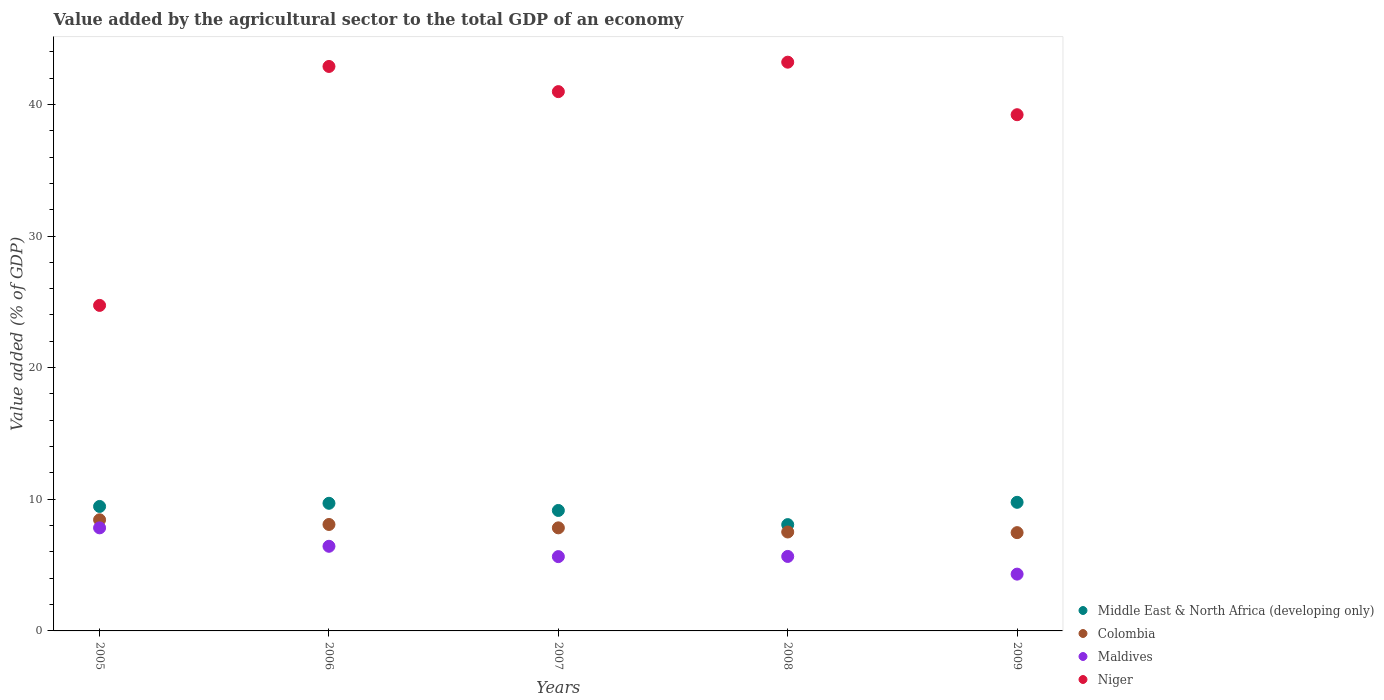How many different coloured dotlines are there?
Ensure brevity in your answer.  4. Is the number of dotlines equal to the number of legend labels?
Provide a succinct answer. Yes. What is the value added by the agricultural sector to the total GDP in Niger in 2008?
Give a very brief answer. 43.21. Across all years, what is the maximum value added by the agricultural sector to the total GDP in Colombia?
Your answer should be very brief. 8.44. Across all years, what is the minimum value added by the agricultural sector to the total GDP in Colombia?
Your answer should be very brief. 7.47. In which year was the value added by the agricultural sector to the total GDP in Middle East & North Africa (developing only) maximum?
Give a very brief answer. 2009. In which year was the value added by the agricultural sector to the total GDP in Middle East & North Africa (developing only) minimum?
Ensure brevity in your answer.  2008. What is the total value added by the agricultural sector to the total GDP in Middle East & North Africa (developing only) in the graph?
Offer a very short reply. 46.15. What is the difference between the value added by the agricultural sector to the total GDP in Middle East & North Africa (developing only) in 2006 and that in 2009?
Offer a terse response. -0.07. What is the difference between the value added by the agricultural sector to the total GDP in Middle East & North Africa (developing only) in 2008 and the value added by the agricultural sector to the total GDP in Colombia in 2009?
Keep it short and to the point. 0.61. What is the average value added by the agricultural sector to the total GDP in Colombia per year?
Your response must be concise. 7.87. In the year 2008, what is the difference between the value added by the agricultural sector to the total GDP in Maldives and value added by the agricultural sector to the total GDP in Middle East & North Africa (developing only)?
Provide a succinct answer. -2.42. What is the ratio of the value added by the agricultural sector to the total GDP in Maldives in 2006 to that in 2009?
Your answer should be very brief. 1.49. What is the difference between the highest and the second highest value added by the agricultural sector to the total GDP in Niger?
Provide a short and direct response. 0.32. What is the difference between the highest and the lowest value added by the agricultural sector to the total GDP in Middle East & North Africa (developing only)?
Give a very brief answer. 1.69. In how many years, is the value added by the agricultural sector to the total GDP in Middle East & North Africa (developing only) greater than the average value added by the agricultural sector to the total GDP in Middle East & North Africa (developing only) taken over all years?
Provide a succinct answer. 3. Is the sum of the value added by the agricultural sector to the total GDP in Niger in 2005 and 2008 greater than the maximum value added by the agricultural sector to the total GDP in Colombia across all years?
Offer a very short reply. Yes. Is it the case that in every year, the sum of the value added by the agricultural sector to the total GDP in Colombia and value added by the agricultural sector to the total GDP in Niger  is greater than the value added by the agricultural sector to the total GDP in Maldives?
Offer a very short reply. Yes. Does the value added by the agricultural sector to the total GDP in Maldives monotonically increase over the years?
Make the answer very short. No. Is the value added by the agricultural sector to the total GDP in Middle East & North Africa (developing only) strictly less than the value added by the agricultural sector to the total GDP in Colombia over the years?
Your response must be concise. No. How many dotlines are there?
Your answer should be compact. 4. Does the graph contain any zero values?
Keep it short and to the point. No. Does the graph contain grids?
Provide a short and direct response. No. Where does the legend appear in the graph?
Your answer should be compact. Bottom right. How many legend labels are there?
Keep it short and to the point. 4. What is the title of the graph?
Offer a terse response. Value added by the agricultural sector to the total GDP of an economy. Does "Brunei Darussalam" appear as one of the legend labels in the graph?
Ensure brevity in your answer.  No. What is the label or title of the Y-axis?
Ensure brevity in your answer.  Value added (% of GDP). What is the Value added (% of GDP) of Middle East & North Africa (developing only) in 2005?
Give a very brief answer. 9.46. What is the Value added (% of GDP) of Colombia in 2005?
Offer a very short reply. 8.44. What is the Value added (% of GDP) in Maldives in 2005?
Offer a very short reply. 7.83. What is the Value added (% of GDP) in Niger in 2005?
Your answer should be compact. 24.73. What is the Value added (% of GDP) in Middle East & North Africa (developing only) in 2006?
Your response must be concise. 9.7. What is the Value added (% of GDP) of Colombia in 2006?
Make the answer very short. 8.09. What is the Value added (% of GDP) in Maldives in 2006?
Offer a terse response. 6.43. What is the Value added (% of GDP) in Niger in 2006?
Offer a terse response. 42.88. What is the Value added (% of GDP) of Middle East & North Africa (developing only) in 2007?
Keep it short and to the point. 9.15. What is the Value added (% of GDP) in Colombia in 2007?
Your answer should be very brief. 7.83. What is the Value added (% of GDP) in Maldives in 2007?
Keep it short and to the point. 5.65. What is the Value added (% of GDP) of Niger in 2007?
Your response must be concise. 40.97. What is the Value added (% of GDP) in Middle East & North Africa (developing only) in 2008?
Give a very brief answer. 8.08. What is the Value added (% of GDP) of Colombia in 2008?
Ensure brevity in your answer.  7.52. What is the Value added (% of GDP) of Maldives in 2008?
Ensure brevity in your answer.  5.66. What is the Value added (% of GDP) of Niger in 2008?
Provide a short and direct response. 43.21. What is the Value added (% of GDP) of Middle East & North Africa (developing only) in 2009?
Your answer should be very brief. 9.77. What is the Value added (% of GDP) in Colombia in 2009?
Provide a succinct answer. 7.47. What is the Value added (% of GDP) of Maldives in 2009?
Ensure brevity in your answer.  4.31. What is the Value added (% of GDP) in Niger in 2009?
Give a very brief answer. 39.21. Across all years, what is the maximum Value added (% of GDP) in Middle East & North Africa (developing only)?
Offer a very short reply. 9.77. Across all years, what is the maximum Value added (% of GDP) of Colombia?
Offer a terse response. 8.44. Across all years, what is the maximum Value added (% of GDP) in Maldives?
Provide a succinct answer. 7.83. Across all years, what is the maximum Value added (% of GDP) in Niger?
Your answer should be very brief. 43.21. Across all years, what is the minimum Value added (% of GDP) in Middle East & North Africa (developing only)?
Provide a succinct answer. 8.08. Across all years, what is the minimum Value added (% of GDP) of Colombia?
Offer a terse response. 7.47. Across all years, what is the minimum Value added (% of GDP) of Maldives?
Make the answer very short. 4.31. Across all years, what is the minimum Value added (% of GDP) in Niger?
Provide a short and direct response. 24.73. What is the total Value added (% of GDP) in Middle East & North Africa (developing only) in the graph?
Provide a short and direct response. 46.15. What is the total Value added (% of GDP) in Colombia in the graph?
Provide a succinct answer. 39.34. What is the total Value added (% of GDP) of Maldives in the graph?
Provide a short and direct response. 29.88. What is the total Value added (% of GDP) of Niger in the graph?
Give a very brief answer. 191. What is the difference between the Value added (% of GDP) in Middle East & North Africa (developing only) in 2005 and that in 2006?
Offer a terse response. -0.24. What is the difference between the Value added (% of GDP) of Colombia in 2005 and that in 2006?
Give a very brief answer. 0.36. What is the difference between the Value added (% of GDP) of Maldives in 2005 and that in 2006?
Ensure brevity in your answer.  1.4. What is the difference between the Value added (% of GDP) of Niger in 2005 and that in 2006?
Make the answer very short. -18.15. What is the difference between the Value added (% of GDP) in Middle East & North Africa (developing only) in 2005 and that in 2007?
Your answer should be compact. 0.3. What is the difference between the Value added (% of GDP) in Colombia in 2005 and that in 2007?
Offer a very short reply. 0.61. What is the difference between the Value added (% of GDP) in Maldives in 2005 and that in 2007?
Your answer should be very brief. 2.18. What is the difference between the Value added (% of GDP) of Niger in 2005 and that in 2007?
Provide a succinct answer. -16.24. What is the difference between the Value added (% of GDP) in Middle East & North Africa (developing only) in 2005 and that in 2008?
Your response must be concise. 1.38. What is the difference between the Value added (% of GDP) of Colombia in 2005 and that in 2008?
Offer a terse response. 0.93. What is the difference between the Value added (% of GDP) in Maldives in 2005 and that in 2008?
Ensure brevity in your answer.  2.17. What is the difference between the Value added (% of GDP) of Niger in 2005 and that in 2008?
Your answer should be very brief. -18.48. What is the difference between the Value added (% of GDP) in Middle East & North Africa (developing only) in 2005 and that in 2009?
Give a very brief answer. -0.31. What is the difference between the Value added (% of GDP) of Maldives in 2005 and that in 2009?
Your answer should be very brief. 3.52. What is the difference between the Value added (% of GDP) in Niger in 2005 and that in 2009?
Your answer should be very brief. -14.49. What is the difference between the Value added (% of GDP) in Middle East & North Africa (developing only) in 2006 and that in 2007?
Your response must be concise. 0.54. What is the difference between the Value added (% of GDP) in Colombia in 2006 and that in 2007?
Provide a short and direct response. 0.26. What is the difference between the Value added (% of GDP) of Maldives in 2006 and that in 2007?
Provide a succinct answer. 0.78. What is the difference between the Value added (% of GDP) of Niger in 2006 and that in 2007?
Provide a succinct answer. 1.91. What is the difference between the Value added (% of GDP) in Middle East & North Africa (developing only) in 2006 and that in 2008?
Give a very brief answer. 1.62. What is the difference between the Value added (% of GDP) of Colombia in 2006 and that in 2008?
Give a very brief answer. 0.57. What is the difference between the Value added (% of GDP) in Maldives in 2006 and that in 2008?
Offer a terse response. 0.77. What is the difference between the Value added (% of GDP) of Niger in 2006 and that in 2008?
Make the answer very short. -0.33. What is the difference between the Value added (% of GDP) of Middle East & North Africa (developing only) in 2006 and that in 2009?
Offer a very short reply. -0.07. What is the difference between the Value added (% of GDP) of Colombia in 2006 and that in 2009?
Give a very brief answer. 0.62. What is the difference between the Value added (% of GDP) in Maldives in 2006 and that in 2009?
Your answer should be compact. 2.12. What is the difference between the Value added (% of GDP) in Niger in 2006 and that in 2009?
Your response must be concise. 3.67. What is the difference between the Value added (% of GDP) in Middle East & North Africa (developing only) in 2007 and that in 2008?
Keep it short and to the point. 1.08. What is the difference between the Value added (% of GDP) in Colombia in 2007 and that in 2008?
Ensure brevity in your answer.  0.31. What is the difference between the Value added (% of GDP) in Maldives in 2007 and that in 2008?
Give a very brief answer. -0.01. What is the difference between the Value added (% of GDP) in Niger in 2007 and that in 2008?
Ensure brevity in your answer.  -2.24. What is the difference between the Value added (% of GDP) in Middle East & North Africa (developing only) in 2007 and that in 2009?
Your answer should be very brief. -0.62. What is the difference between the Value added (% of GDP) of Colombia in 2007 and that in 2009?
Provide a succinct answer. 0.36. What is the difference between the Value added (% of GDP) of Maldives in 2007 and that in 2009?
Provide a short and direct response. 1.33. What is the difference between the Value added (% of GDP) in Niger in 2007 and that in 2009?
Offer a very short reply. 1.75. What is the difference between the Value added (% of GDP) in Middle East & North Africa (developing only) in 2008 and that in 2009?
Make the answer very short. -1.69. What is the difference between the Value added (% of GDP) of Colombia in 2008 and that in 2009?
Keep it short and to the point. 0.05. What is the difference between the Value added (% of GDP) in Maldives in 2008 and that in 2009?
Provide a short and direct response. 1.34. What is the difference between the Value added (% of GDP) in Niger in 2008 and that in 2009?
Ensure brevity in your answer.  3.99. What is the difference between the Value added (% of GDP) in Middle East & North Africa (developing only) in 2005 and the Value added (% of GDP) in Colombia in 2006?
Your answer should be compact. 1.37. What is the difference between the Value added (% of GDP) of Middle East & North Africa (developing only) in 2005 and the Value added (% of GDP) of Maldives in 2006?
Your answer should be compact. 3.03. What is the difference between the Value added (% of GDP) of Middle East & North Africa (developing only) in 2005 and the Value added (% of GDP) of Niger in 2006?
Your answer should be very brief. -33.42. What is the difference between the Value added (% of GDP) in Colombia in 2005 and the Value added (% of GDP) in Maldives in 2006?
Give a very brief answer. 2.01. What is the difference between the Value added (% of GDP) in Colombia in 2005 and the Value added (% of GDP) in Niger in 2006?
Your answer should be very brief. -34.44. What is the difference between the Value added (% of GDP) of Maldives in 2005 and the Value added (% of GDP) of Niger in 2006?
Offer a terse response. -35.05. What is the difference between the Value added (% of GDP) in Middle East & North Africa (developing only) in 2005 and the Value added (% of GDP) in Colombia in 2007?
Your answer should be compact. 1.63. What is the difference between the Value added (% of GDP) of Middle East & North Africa (developing only) in 2005 and the Value added (% of GDP) of Maldives in 2007?
Provide a succinct answer. 3.81. What is the difference between the Value added (% of GDP) of Middle East & North Africa (developing only) in 2005 and the Value added (% of GDP) of Niger in 2007?
Your answer should be very brief. -31.51. What is the difference between the Value added (% of GDP) in Colombia in 2005 and the Value added (% of GDP) in Maldives in 2007?
Your response must be concise. 2.8. What is the difference between the Value added (% of GDP) of Colombia in 2005 and the Value added (% of GDP) of Niger in 2007?
Keep it short and to the point. -32.53. What is the difference between the Value added (% of GDP) of Maldives in 2005 and the Value added (% of GDP) of Niger in 2007?
Your answer should be very brief. -33.14. What is the difference between the Value added (% of GDP) in Middle East & North Africa (developing only) in 2005 and the Value added (% of GDP) in Colombia in 2008?
Provide a short and direct response. 1.94. What is the difference between the Value added (% of GDP) in Middle East & North Africa (developing only) in 2005 and the Value added (% of GDP) in Maldives in 2008?
Ensure brevity in your answer.  3.8. What is the difference between the Value added (% of GDP) of Middle East & North Africa (developing only) in 2005 and the Value added (% of GDP) of Niger in 2008?
Provide a short and direct response. -33.75. What is the difference between the Value added (% of GDP) of Colombia in 2005 and the Value added (% of GDP) of Maldives in 2008?
Your answer should be compact. 2.78. What is the difference between the Value added (% of GDP) in Colombia in 2005 and the Value added (% of GDP) in Niger in 2008?
Keep it short and to the point. -34.76. What is the difference between the Value added (% of GDP) in Maldives in 2005 and the Value added (% of GDP) in Niger in 2008?
Keep it short and to the point. -35.38. What is the difference between the Value added (% of GDP) in Middle East & North Africa (developing only) in 2005 and the Value added (% of GDP) in Colombia in 2009?
Make the answer very short. 1.99. What is the difference between the Value added (% of GDP) of Middle East & North Africa (developing only) in 2005 and the Value added (% of GDP) of Maldives in 2009?
Provide a short and direct response. 5.14. What is the difference between the Value added (% of GDP) of Middle East & North Africa (developing only) in 2005 and the Value added (% of GDP) of Niger in 2009?
Keep it short and to the point. -29.76. What is the difference between the Value added (% of GDP) in Colombia in 2005 and the Value added (% of GDP) in Maldives in 2009?
Offer a very short reply. 4.13. What is the difference between the Value added (% of GDP) of Colombia in 2005 and the Value added (% of GDP) of Niger in 2009?
Keep it short and to the point. -30.77. What is the difference between the Value added (% of GDP) of Maldives in 2005 and the Value added (% of GDP) of Niger in 2009?
Make the answer very short. -31.38. What is the difference between the Value added (% of GDP) in Middle East & North Africa (developing only) in 2006 and the Value added (% of GDP) in Colombia in 2007?
Provide a succinct answer. 1.87. What is the difference between the Value added (% of GDP) of Middle East & North Africa (developing only) in 2006 and the Value added (% of GDP) of Maldives in 2007?
Provide a short and direct response. 4.05. What is the difference between the Value added (% of GDP) in Middle East & North Africa (developing only) in 2006 and the Value added (% of GDP) in Niger in 2007?
Offer a terse response. -31.27. What is the difference between the Value added (% of GDP) in Colombia in 2006 and the Value added (% of GDP) in Maldives in 2007?
Your response must be concise. 2.44. What is the difference between the Value added (% of GDP) in Colombia in 2006 and the Value added (% of GDP) in Niger in 2007?
Your response must be concise. -32.88. What is the difference between the Value added (% of GDP) of Maldives in 2006 and the Value added (% of GDP) of Niger in 2007?
Give a very brief answer. -34.54. What is the difference between the Value added (% of GDP) of Middle East & North Africa (developing only) in 2006 and the Value added (% of GDP) of Colombia in 2008?
Make the answer very short. 2.18. What is the difference between the Value added (% of GDP) in Middle East & North Africa (developing only) in 2006 and the Value added (% of GDP) in Maldives in 2008?
Make the answer very short. 4.04. What is the difference between the Value added (% of GDP) of Middle East & North Africa (developing only) in 2006 and the Value added (% of GDP) of Niger in 2008?
Keep it short and to the point. -33.51. What is the difference between the Value added (% of GDP) in Colombia in 2006 and the Value added (% of GDP) in Maldives in 2008?
Your response must be concise. 2.43. What is the difference between the Value added (% of GDP) in Colombia in 2006 and the Value added (% of GDP) in Niger in 2008?
Your answer should be very brief. -35.12. What is the difference between the Value added (% of GDP) of Maldives in 2006 and the Value added (% of GDP) of Niger in 2008?
Give a very brief answer. -36.78. What is the difference between the Value added (% of GDP) of Middle East & North Africa (developing only) in 2006 and the Value added (% of GDP) of Colombia in 2009?
Your answer should be compact. 2.23. What is the difference between the Value added (% of GDP) in Middle East & North Africa (developing only) in 2006 and the Value added (% of GDP) in Maldives in 2009?
Offer a very short reply. 5.38. What is the difference between the Value added (% of GDP) in Middle East & North Africa (developing only) in 2006 and the Value added (% of GDP) in Niger in 2009?
Your answer should be compact. -29.52. What is the difference between the Value added (% of GDP) in Colombia in 2006 and the Value added (% of GDP) in Maldives in 2009?
Offer a very short reply. 3.77. What is the difference between the Value added (% of GDP) of Colombia in 2006 and the Value added (% of GDP) of Niger in 2009?
Ensure brevity in your answer.  -31.13. What is the difference between the Value added (% of GDP) in Maldives in 2006 and the Value added (% of GDP) in Niger in 2009?
Your answer should be very brief. -32.78. What is the difference between the Value added (% of GDP) in Middle East & North Africa (developing only) in 2007 and the Value added (% of GDP) in Colombia in 2008?
Make the answer very short. 1.64. What is the difference between the Value added (% of GDP) in Middle East & North Africa (developing only) in 2007 and the Value added (% of GDP) in Maldives in 2008?
Offer a very short reply. 3.49. What is the difference between the Value added (% of GDP) in Middle East & North Africa (developing only) in 2007 and the Value added (% of GDP) in Niger in 2008?
Your response must be concise. -34.05. What is the difference between the Value added (% of GDP) of Colombia in 2007 and the Value added (% of GDP) of Maldives in 2008?
Ensure brevity in your answer.  2.17. What is the difference between the Value added (% of GDP) in Colombia in 2007 and the Value added (% of GDP) in Niger in 2008?
Offer a very short reply. -35.38. What is the difference between the Value added (% of GDP) of Maldives in 2007 and the Value added (% of GDP) of Niger in 2008?
Give a very brief answer. -37.56. What is the difference between the Value added (% of GDP) in Middle East & North Africa (developing only) in 2007 and the Value added (% of GDP) in Colombia in 2009?
Offer a very short reply. 1.68. What is the difference between the Value added (% of GDP) of Middle East & North Africa (developing only) in 2007 and the Value added (% of GDP) of Maldives in 2009?
Your response must be concise. 4.84. What is the difference between the Value added (% of GDP) in Middle East & North Africa (developing only) in 2007 and the Value added (% of GDP) in Niger in 2009?
Give a very brief answer. -30.06. What is the difference between the Value added (% of GDP) of Colombia in 2007 and the Value added (% of GDP) of Maldives in 2009?
Keep it short and to the point. 3.52. What is the difference between the Value added (% of GDP) of Colombia in 2007 and the Value added (% of GDP) of Niger in 2009?
Keep it short and to the point. -31.38. What is the difference between the Value added (% of GDP) of Maldives in 2007 and the Value added (% of GDP) of Niger in 2009?
Offer a very short reply. -33.57. What is the difference between the Value added (% of GDP) in Middle East & North Africa (developing only) in 2008 and the Value added (% of GDP) in Colombia in 2009?
Make the answer very short. 0.61. What is the difference between the Value added (% of GDP) in Middle East & North Africa (developing only) in 2008 and the Value added (% of GDP) in Maldives in 2009?
Your answer should be compact. 3.76. What is the difference between the Value added (% of GDP) in Middle East & North Africa (developing only) in 2008 and the Value added (% of GDP) in Niger in 2009?
Your response must be concise. -31.14. What is the difference between the Value added (% of GDP) in Colombia in 2008 and the Value added (% of GDP) in Maldives in 2009?
Make the answer very short. 3.2. What is the difference between the Value added (% of GDP) in Colombia in 2008 and the Value added (% of GDP) in Niger in 2009?
Make the answer very short. -31.7. What is the difference between the Value added (% of GDP) of Maldives in 2008 and the Value added (% of GDP) of Niger in 2009?
Your answer should be very brief. -33.56. What is the average Value added (% of GDP) of Middle East & North Africa (developing only) per year?
Provide a short and direct response. 9.23. What is the average Value added (% of GDP) of Colombia per year?
Offer a very short reply. 7.87. What is the average Value added (% of GDP) of Maldives per year?
Offer a very short reply. 5.98. What is the average Value added (% of GDP) in Niger per year?
Provide a short and direct response. 38.2. In the year 2005, what is the difference between the Value added (% of GDP) of Middle East & North Africa (developing only) and Value added (% of GDP) of Colombia?
Offer a terse response. 1.01. In the year 2005, what is the difference between the Value added (% of GDP) in Middle East & North Africa (developing only) and Value added (% of GDP) in Maldives?
Make the answer very short. 1.63. In the year 2005, what is the difference between the Value added (% of GDP) of Middle East & North Africa (developing only) and Value added (% of GDP) of Niger?
Provide a succinct answer. -15.27. In the year 2005, what is the difference between the Value added (% of GDP) in Colombia and Value added (% of GDP) in Maldives?
Offer a very short reply. 0.61. In the year 2005, what is the difference between the Value added (% of GDP) of Colombia and Value added (% of GDP) of Niger?
Make the answer very short. -16.29. In the year 2005, what is the difference between the Value added (% of GDP) of Maldives and Value added (% of GDP) of Niger?
Make the answer very short. -16.9. In the year 2006, what is the difference between the Value added (% of GDP) of Middle East & North Africa (developing only) and Value added (% of GDP) of Colombia?
Give a very brief answer. 1.61. In the year 2006, what is the difference between the Value added (% of GDP) of Middle East & North Africa (developing only) and Value added (% of GDP) of Maldives?
Keep it short and to the point. 3.27. In the year 2006, what is the difference between the Value added (% of GDP) in Middle East & North Africa (developing only) and Value added (% of GDP) in Niger?
Your answer should be very brief. -33.19. In the year 2006, what is the difference between the Value added (% of GDP) in Colombia and Value added (% of GDP) in Maldives?
Ensure brevity in your answer.  1.66. In the year 2006, what is the difference between the Value added (% of GDP) of Colombia and Value added (% of GDP) of Niger?
Ensure brevity in your answer.  -34.79. In the year 2006, what is the difference between the Value added (% of GDP) in Maldives and Value added (% of GDP) in Niger?
Your answer should be very brief. -36.45. In the year 2007, what is the difference between the Value added (% of GDP) of Middle East & North Africa (developing only) and Value added (% of GDP) of Colombia?
Your answer should be compact. 1.32. In the year 2007, what is the difference between the Value added (% of GDP) of Middle East & North Africa (developing only) and Value added (% of GDP) of Maldives?
Your answer should be very brief. 3.51. In the year 2007, what is the difference between the Value added (% of GDP) in Middle East & North Africa (developing only) and Value added (% of GDP) in Niger?
Your answer should be very brief. -31.82. In the year 2007, what is the difference between the Value added (% of GDP) of Colombia and Value added (% of GDP) of Maldives?
Make the answer very short. 2.18. In the year 2007, what is the difference between the Value added (% of GDP) of Colombia and Value added (% of GDP) of Niger?
Your answer should be very brief. -33.14. In the year 2007, what is the difference between the Value added (% of GDP) of Maldives and Value added (% of GDP) of Niger?
Your answer should be compact. -35.32. In the year 2008, what is the difference between the Value added (% of GDP) in Middle East & North Africa (developing only) and Value added (% of GDP) in Colombia?
Provide a short and direct response. 0.56. In the year 2008, what is the difference between the Value added (% of GDP) of Middle East & North Africa (developing only) and Value added (% of GDP) of Maldives?
Ensure brevity in your answer.  2.42. In the year 2008, what is the difference between the Value added (% of GDP) in Middle East & North Africa (developing only) and Value added (% of GDP) in Niger?
Your answer should be compact. -35.13. In the year 2008, what is the difference between the Value added (% of GDP) of Colombia and Value added (% of GDP) of Maldives?
Keep it short and to the point. 1.86. In the year 2008, what is the difference between the Value added (% of GDP) in Colombia and Value added (% of GDP) in Niger?
Give a very brief answer. -35.69. In the year 2008, what is the difference between the Value added (% of GDP) of Maldives and Value added (% of GDP) of Niger?
Keep it short and to the point. -37.55. In the year 2009, what is the difference between the Value added (% of GDP) of Middle East & North Africa (developing only) and Value added (% of GDP) of Colombia?
Make the answer very short. 2.3. In the year 2009, what is the difference between the Value added (% of GDP) in Middle East & North Africa (developing only) and Value added (% of GDP) in Maldives?
Your response must be concise. 5.46. In the year 2009, what is the difference between the Value added (% of GDP) of Middle East & North Africa (developing only) and Value added (% of GDP) of Niger?
Make the answer very short. -29.44. In the year 2009, what is the difference between the Value added (% of GDP) in Colombia and Value added (% of GDP) in Maldives?
Ensure brevity in your answer.  3.15. In the year 2009, what is the difference between the Value added (% of GDP) of Colombia and Value added (% of GDP) of Niger?
Provide a succinct answer. -31.75. In the year 2009, what is the difference between the Value added (% of GDP) of Maldives and Value added (% of GDP) of Niger?
Make the answer very short. -34.9. What is the ratio of the Value added (% of GDP) in Middle East & North Africa (developing only) in 2005 to that in 2006?
Keep it short and to the point. 0.98. What is the ratio of the Value added (% of GDP) of Colombia in 2005 to that in 2006?
Offer a very short reply. 1.04. What is the ratio of the Value added (% of GDP) of Maldives in 2005 to that in 2006?
Keep it short and to the point. 1.22. What is the ratio of the Value added (% of GDP) in Niger in 2005 to that in 2006?
Your response must be concise. 0.58. What is the ratio of the Value added (% of GDP) in Colombia in 2005 to that in 2007?
Your response must be concise. 1.08. What is the ratio of the Value added (% of GDP) in Maldives in 2005 to that in 2007?
Keep it short and to the point. 1.39. What is the ratio of the Value added (% of GDP) of Niger in 2005 to that in 2007?
Offer a terse response. 0.6. What is the ratio of the Value added (% of GDP) in Middle East & North Africa (developing only) in 2005 to that in 2008?
Provide a short and direct response. 1.17. What is the ratio of the Value added (% of GDP) in Colombia in 2005 to that in 2008?
Give a very brief answer. 1.12. What is the ratio of the Value added (% of GDP) of Maldives in 2005 to that in 2008?
Your response must be concise. 1.38. What is the ratio of the Value added (% of GDP) in Niger in 2005 to that in 2008?
Your response must be concise. 0.57. What is the ratio of the Value added (% of GDP) of Middle East & North Africa (developing only) in 2005 to that in 2009?
Make the answer very short. 0.97. What is the ratio of the Value added (% of GDP) of Colombia in 2005 to that in 2009?
Make the answer very short. 1.13. What is the ratio of the Value added (% of GDP) of Maldives in 2005 to that in 2009?
Offer a very short reply. 1.81. What is the ratio of the Value added (% of GDP) of Niger in 2005 to that in 2009?
Provide a short and direct response. 0.63. What is the ratio of the Value added (% of GDP) in Middle East & North Africa (developing only) in 2006 to that in 2007?
Provide a short and direct response. 1.06. What is the ratio of the Value added (% of GDP) of Colombia in 2006 to that in 2007?
Your answer should be compact. 1.03. What is the ratio of the Value added (% of GDP) in Maldives in 2006 to that in 2007?
Give a very brief answer. 1.14. What is the ratio of the Value added (% of GDP) of Niger in 2006 to that in 2007?
Ensure brevity in your answer.  1.05. What is the ratio of the Value added (% of GDP) in Middle East & North Africa (developing only) in 2006 to that in 2008?
Provide a succinct answer. 1.2. What is the ratio of the Value added (% of GDP) in Colombia in 2006 to that in 2008?
Offer a very short reply. 1.08. What is the ratio of the Value added (% of GDP) in Maldives in 2006 to that in 2008?
Your answer should be very brief. 1.14. What is the ratio of the Value added (% of GDP) in Niger in 2006 to that in 2008?
Offer a terse response. 0.99. What is the ratio of the Value added (% of GDP) of Colombia in 2006 to that in 2009?
Give a very brief answer. 1.08. What is the ratio of the Value added (% of GDP) in Maldives in 2006 to that in 2009?
Your answer should be compact. 1.49. What is the ratio of the Value added (% of GDP) of Niger in 2006 to that in 2009?
Provide a succinct answer. 1.09. What is the ratio of the Value added (% of GDP) of Middle East & North Africa (developing only) in 2007 to that in 2008?
Ensure brevity in your answer.  1.13. What is the ratio of the Value added (% of GDP) in Colombia in 2007 to that in 2008?
Your answer should be very brief. 1.04. What is the ratio of the Value added (% of GDP) of Maldives in 2007 to that in 2008?
Keep it short and to the point. 1. What is the ratio of the Value added (% of GDP) of Niger in 2007 to that in 2008?
Offer a very short reply. 0.95. What is the ratio of the Value added (% of GDP) in Middle East & North Africa (developing only) in 2007 to that in 2009?
Your response must be concise. 0.94. What is the ratio of the Value added (% of GDP) of Colombia in 2007 to that in 2009?
Your response must be concise. 1.05. What is the ratio of the Value added (% of GDP) of Maldives in 2007 to that in 2009?
Provide a succinct answer. 1.31. What is the ratio of the Value added (% of GDP) of Niger in 2007 to that in 2009?
Ensure brevity in your answer.  1.04. What is the ratio of the Value added (% of GDP) in Middle East & North Africa (developing only) in 2008 to that in 2009?
Keep it short and to the point. 0.83. What is the ratio of the Value added (% of GDP) in Colombia in 2008 to that in 2009?
Provide a succinct answer. 1.01. What is the ratio of the Value added (% of GDP) of Maldives in 2008 to that in 2009?
Provide a short and direct response. 1.31. What is the ratio of the Value added (% of GDP) of Niger in 2008 to that in 2009?
Your answer should be compact. 1.1. What is the difference between the highest and the second highest Value added (% of GDP) of Middle East & North Africa (developing only)?
Provide a short and direct response. 0.07. What is the difference between the highest and the second highest Value added (% of GDP) of Colombia?
Provide a short and direct response. 0.36. What is the difference between the highest and the second highest Value added (% of GDP) in Maldives?
Your answer should be compact. 1.4. What is the difference between the highest and the second highest Value added (% of GDP) in Niger?
Ensure brevity in your answer.  0.33. What is the difference between the highest and the lowest Value added (% of GDP) of Middle East & North Africa (developing only)?
Your answer should be compact. 1.69. What is the difference between the highest and the lowest Value added (% of GDP) in Maldives?
Your answer should be very brief. 3.52. What is the difference between the highest and the lowest Value added (% of GDP) of Niger?
Give a very brief answer. 18.48. 